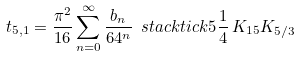Convert formula to latex. <formula><loc_0><loc_0><loc_500><loc_500>t _ { 5 , 1 } = \frac { \pi ^ { 2 } } { 1 6 } \sum _ { n = 0 } ^ { \infty } \frac { b _ { n } } { 6 4 ^ { n } } \ s t a c k t i c k { 5 } \frac { 1 } { 4 } \, K _ { 1 5 } K _ { 5 / 3 }</formula> 